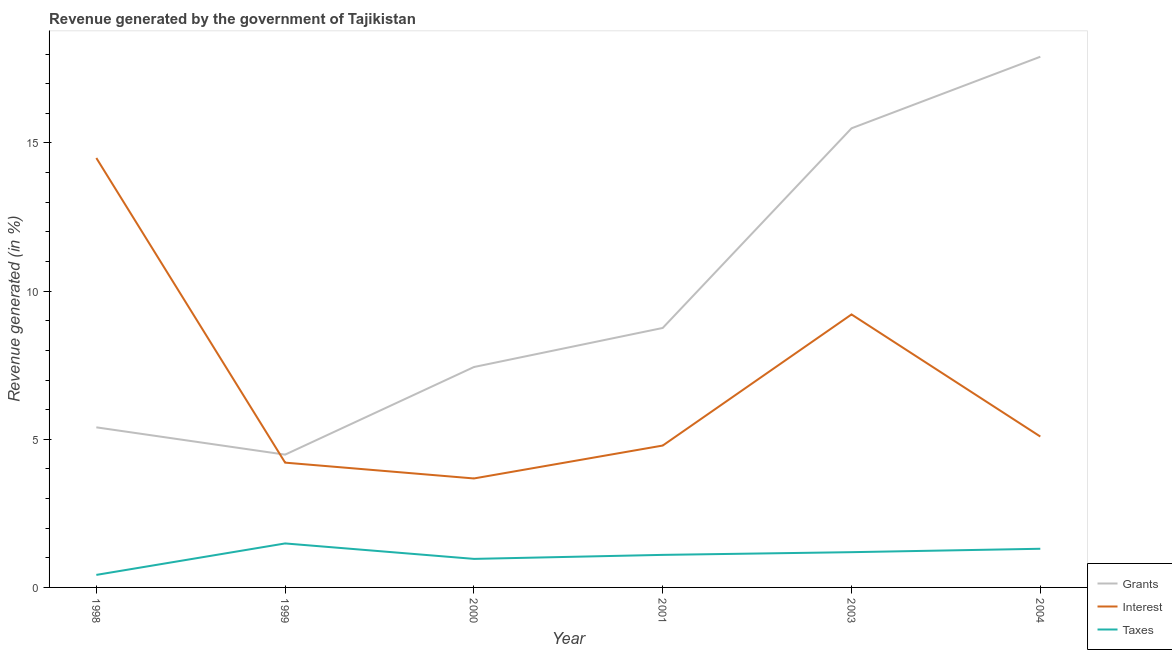Does the line corresponding to percentage of revenue generated by interest intersect with the line corresponding to percentage of revenue generated by taxes?
Ensure brevity in your answer.  No. What is the percentage of revenue generated by taxes in 2001?
Your answer should be very brief. 1.1. Across all years, what is the maximum percentage of revenue generated by grants?
Make the answer very short. 17.91. Across all years, what is the minimum percentage of revenue generated by grants?
Provide a succinct answer. 4.48. In which year was the percentage of revenue generated by taxes minimum?
Your response must be concise. 1998. What is the total percentage of revenue generated by taxes in the graph?
Offer a very short reply. 6.46. What is the difference between the percentage of revenue generated by interest in 1999 and that in 2001?
Ensure brevity in your answer.  -0.58. What is the difference between the percentage of revenue generated by taxes in 2001 and the percentage of revenue generated by grants in 2003?
Offer a terse response. -14.4. What is the average percentage of revenue generated by grants per year?
Provide a succinct answer. 9.91. In the year 1998, what is the difference between the percentage of revenue generated by interest and percentage of revenue generated by grants?
Your answer should be compact. 9.09. What is the ratio of the percentage of revenue generated by grants in 1998 to that in 2000?
Provide a short and direct response. 0.73. Is the percentage of revenue generated by taxes in 1999 less than that in 2003?
Your response must be concise. No. Is the difference between the percentage of revenue generated by interest in 2000 and 2004 greater than the difference between the percentage of revenue generated by grants in 2000 and 2004?
Provide a short and direct response. Yes. What is the difference between the highest and the second highest percentage of revenue generated by taxes?
Your response must be concise. 0.18. What is the difference between the highest and the lowest percentage of revenue generated by taxes?
Offer a very short reply. 1.06. Is it the case that in every year, the sum of the percentage of revenue generated by grants and percentage of revenue generated by interest is greater than the percentage of revenue generated by taxes?
Your answer should be compact. Yes. Does the percentage of revenue generated by interest monotonically increase over the years?
Give a very brief answer. No. Is the percentage of revenue generated by taxes strictly less than the percentage of revenue generated by grants over the years?
Your answer should be compact. Yes. How many lines are there?
Offer a very short reply. 3. How many years are there in the graph?
Offer a terse response. 6. Are the values on the major ticks of Y-axis written in scientific E-notation?
Give a very brief answer. No. Does the graph contain any zero values?
Keep it short and to the point. No. How many legend labels are there?
Offer a terse response. 3. What is the title of the graph?
Offer a terse response. Revenue generated by the government of Tajikistan. Does "Infant(female)" appear as one of the legend labels in the graph?
Offer a very short reply. No. What is the label or title of the X-axis?
Provide a short and direct response. Year. What is the label or title of the Y-axis?
Ensure brevity in your answer.  Revenue generated (in %). What is the Revenue generated (in %) in Grants in 1998?
Your answer should be very brief. 5.4. What is the Revenue generated (in %) of Interest in 1998?
Give a very brief answer. 14.49. What is the Revenue generated (in %) of Taxes in 1998?
Ensure brevity in your answer.  0.42. What is the Revenue generated (in %) in Grants in 1999?
Provide a succinct answer. 4.48. What is the Revenue generated (in %) in Interest in 1999?
Ensure brevity in your answer.  4.21. What is the Revenue generated (in %) of Taxes in 1999?
Make the answer very short. 1.48. What is the Revenue generated (in %) in Grants in 2000?
Offer a very short reply. 7.44. What is the Revenue generated (in %) in Interest in 2000?
Offer a very short reply. 3.68. What is the Revenue generated (in %) in Taxes in 2000?
Provide a succinct answer. 0.96. What is the Revenue generated (in %) of Grants in 2001?
Make the answer very short. 8.76. What is the Revenue generated (in %) in Interest in 2001?
Offer a very short reply. 4.79. What is the Revenue generated (in %) in Taxes in 2001?
Make the answer very short. 1.1. What is the Revenue generated (in %) in Grants in 2003?
Offer a very short reply. 15.5. What is the Revenue generated (in %) in Interest in 2003?
Provide a succinct answer. 9.21. What is the Revenue generated (in %) in Taxes in 2003?
Your response must be concise. 1.19. What is the Revenue generated (in %) of Grants in 2004?
Offer a terse response. 17.91. What is the Revenue generated (in %) in Interest in 2004?
Provide a succinct answer. 5.09. What is the Revenue generated (in %) of Taxes in 2004?
Make the answer very short. 1.3. Across all years, what is the maximum Revenue generated (in %) of Grants?
Keep it short and to the point. 17.91. Across all years, what is the maximum Revenue generated (in %) in Interest?
Give a very brief answer. 14.49. Across all years, what is the maximum Revenue generated (in %) of Taxes?
Offer a terse response. 1.48. Across all years, what is the minimum Revenue generated (in %) in Grants?
Your response must be concise. 4.48. Across all years, what is the minimum Revenue generated (in %) in Interest?
Offer a very short reply. 3.68. Across all years, what is the minimum Revenue generated (in %) in Taxes?
Your response must be concise. 0.42. What is the total Revenue generated (in %) of Grants in the graph?
Make the answer very short. 59.49. What is the total Revenue generated (in %) of Interest in the graph?
Your answer should be very brief. 41.48. What is the total Revenue generated (in %) in Taxes in the graph?
Your answer should be very brief. 6.46. What is the difference between the Revenue generated (in %) in Grants in 1998 and that in 1999?
Provide a succinct answer. 0.92. What is the difference between the Revenue generated (in %) in Interest in 1998 and that in 1999?
Give a very brief answer. 10.28. What is the difference between the Revenue generated (in %) in Taxes in 1998 and that in 1999?
Provide a succinct answer. -1.06. What is the difference between the Revenue generated (in %) in Grants in 1998 and that in 2000?
Provide a succinct answer. -2.04. What is the difference between the Revenue generated (in %) in Interest in 1998 and that in 2000?
Your response must be concise. 10.82. What is the difference between the Revenue generated (in %) in Taxes in 1998 and that in 2000?
Ensure brevity in your answer.  -0.54. What is the difference between the Revenue generated (in %) in Grants in 1998 and that in 2001?
Offer a very short reply. -3.35. What is the difference between the Revenue generated (in %) of Interest in 1998 and that in 2001?
Your response must be concise. 9.7. What is the difference between the Revenue generated (in %) of Taxes in 1998 and that in 2001?
Your answer should be compact. -0.68. What is the difference between the Revenue generated (in %) in Grants in 1998 and that in 2003?
Your answer should be compact. -10.09. What is the difference between the Revenue generated (in %) of Interest in 1998 and that in 2003?
Provide a short and direct response. 5.28. What is the difference between the Revenue generated (in %) of Taxes in 1998 and that in 2003?
Your answer should be very brief. -0.77. What is the difference between the Revenue generated (in %) in Grants in 1998 and that in 2004?
Provide a short and direct response. -12.51. What is the difference between the Revenue generated (in %) in Interest in 1998 and that in 2004?
Provide a succinct answer. 9.4. What is the difference between the Revenue generated (in %) in Taxes in 1998 and that in 2004?
Ensure brevity in your answer.  -0.88. What is the difference between the Revenue generated (in %) of Grants in 1999 and that in 2000?
Make the answer very short. -2.96. What is the difference between the Revenue generated (in %) of Interest in 1999 and that in 2000?
Offer a very short reply. 0.53. What is the difference between the Revenue generated (in %) of Taxes in 1999 and that in 2000?
Give a very brief answer. 0.52. What is the difference between the Revenue generated (in %) of Grants in 1999 and that in 2001?
Your response must be concise. -4.28. What is the difference between the Revenue generated (in %) of Interest in 1999 and that in 2001?
Provide a short and direct response. -0.58. What is the difference between the Revenue generated (in %) in Taxes in 1999 and that in 2001?
Give a very brief answer. 0.39. What is the difference between the Revenue generated (in %) of Grants in 1999 and that in 2003?
Keep it short and to the point. -11.01. What is the difference between the Revenue generated (in %) in Interest in 1999 and that in 2003?
Your answer should be compact. -5. What is the difference between the Revenue generated (in %) of Taxes in 1999 and that in 2003?
Your answer should be compact. 0.29. What is the difference between the Revenue generated (in %) in Grants in 1999 and that in 2004?
Keep it short and to the point. -13.43. What is the difference between the Revenue generated (in %) of Interest in 1999 and that in 2004?
Offer a very short reply. -0.88. What is the difference between the Revenue generated (in %) in Taxes in 1999 and that in 2004?
Your answer should be compact. 0.18. What is the difference between the Revenue generated (in %) of Grants in 2000 and that in 2001?
Ensure brevity in your answer.  -1.32. What is the difference between the Revenue generated (in %) in Interest in 2000 and that in 2001?
Give a very brief answer. -1.11. What is the difference between the Revenue generated (in %) of Taxes in 2000 and that in 2001?
Offer a very short reply. -0.14. What is the difference between the Revenue generated (in %) of Grants in 2000 and that in 2003?
Your answer should be compact. -8.06. What is the difference between the Revenue generated (in %) in Interest in 2000 and that in 2003?
Provide a succinct answer. -5.54. What is the difference between the Revenue generated (in %) of Taxes in 2000 and that in 2003?
Your response must be concise. -0.23. What is the difference between the Revenue generated (in %) in Grants in 2000 and that in 2004?
Give a very brief answer. -10.47. What is the difference between the Revenue generated (in %) of Interest in 2000 and that in 2004?
Ensure brevity in your answer.  -1.41. What is the difference between the Revenue generated (in %) in Taxes in 2000 and that in 2004?
Ensure brevity in your answer.  -0.34. What is the difference between the Revenue generated (in %) in Grants in 2001 and that in 2003?
Offer a terse response. -6.74. What is the difference between the Revenue generated (in %) in Interest in 2001 and that in 2003?
Provide a succinct answer. -4.42. What is the difference between the Revenue generated (in %) of Taxes in 2001 and that in 2003?
Your answer should be very brief. -0.09. What is the difference between the Revenue generated (in %) of Grants in 2001 and that in 2004?
Your response must be concise. -9.15. What is the difference between the Revenue generated (in %) in Interest in 2001 and that in 2004?
Provide a short and direct response. -0.3. What is the difference between the Revenue generated (in %) of Taxes in 2001 and that in 2004?
Provide a succinct answer. -0.21. What is the difference between the Revenue generated (in %) in Grants in 2003 and that in 2004?
Your response must be concise. -2.42. What is the difference between the Revenue generated (in %) in Interest in 2003 and that in 2004?
Your answer should be very brief. 4.12. What is the difference between the Revenue generated (in %) in Taxes in 2003 and that in 2004?
Your answer should be compact. -0.12. What is the difference between the Revenue generated (in %) in Grants in 1998 and the Revenue generated (in %) in Interest in 1999?
Provide a succinct answer. 1.19. What is the difference between the Revenue generated (in %) in Grants in 1998 and the Revenue generated (in %) in Taxes in 1999?
Give a very brief answer. 3.92. What is the difference between the Revenue generated (in %) of Interest in 1998 and the Revenue generated (in %) of Taxes in 1999?
Ensure brevity in your answer.  13.01. What is the difference between the Revenue generated (in %) in Grants in 1998 and the Revenue generated (in %) in Interest in 2000?
Provide a succinct answer. 1.73. What is the difference between the Revenue generated (in %) of Grants in 1998 and the Revenue generated (in %) of Taxes in 2000?
Keep it short and to the point. 4.44. What is the difference between the Revenue generated (in %) in Interest in 1998 and the Revenue generated (in %) in Taxes in 2000?
Your answer should be very brief. 13.53. What is the difference between the Revenue generated (in %) of Grants in 1998 and the Revenue generated (in %) of Interest in 2001?
Provide a short and direct response. 0.61. What is the difference between the Revenue generated (in %) in Grants in 1998 and the Revenue generated (in %) in Taxes in 2001?
Keep it short and to the point. 4.3. What is the difference between the Revenue generated (in %) of Interest in 1998 and the Revenue generated (in %) of Taxes in 2001?
Ensure brevity in your answer.  13.39. What is the difference between the Revenue generated (in %) of Grants in 1998 and the Revenue generated (in %) of Interest in 2003?
Your answer should be compact. -3.81. What is the difference between the Revenue generated (in %) of Grants in 1998 and the Revenue generated (in %) of Taxes in 2003?
Offer a very short reply. 4.21. What is the difference between the Revenue generated (in %) of Interest in 1998 and the Revenue generated (in %) of Taxes in 2003?
Make the answer very short. 13.3. What is the difference between the Revenue generated (in %) of Grants in 1998 and the Revenue generated (in %) of Interest in 2004?
Your answer should be very brief. 0.31. What is the difference between the Revenue generated (in %) in Grants in 1998 and the Revenue generated (in %) in Taxes in 2004?
Give a very brief answer. 4.1. What is the difference between the Revenue generated (in %) in Interest in 1998 and the Revenue generated (in %) in Taxes in 2004?
Offer a terse response. 13.19. What is the difference between the Revenue generated (in %) in Grants in 1999 and the Revenue generated (in %) in Interest in 2000?
Give a very brief answer. 0.8. What is the difference between the Revenue generated (in %) of Grants in 1999 and the Revenue generated (in %) of Taxes in 2000?
Your response must be concise. 3.52. What is the difference between the Revenue generated (in %) of Interest in 1999 and the Revenue generated (in %) of Taxes in 2000?
Your response must be concise. 3.25. What is the difference between the Revenue generated (in %) of Grants in 1999 and the Revenue generated (in %) of Interest in 2001?
Your answer should be compact. -0.31. What is the difference between the Revenue generated (in %) of Grants in 1999 and the Revenue generated (in %) of Taxes in 2001?
Make the answer very short. 3.38. What is the difference between the Revenue generated (in %) in Interest in 1999 and the Revenue generated (in %) in Taxes in 2001?
Make the answer very short. 3.11. What is the difference between the Revenue generated (in %) in Grants in 1999 and the Revenue generated (in %) in Interest in 2003?
Your answer should be very brief. -4.73. What is the difference between the Revenue generated (in %) of Grants in 1999 and the Revenue generated (in %) of Taxes in 2003?
Ensure brevity in your answer.  3.29. What is the difference between the Revenue generated (in %) in Interest in 1999 and the Revenue generated (in %) in Taxes in 2003?
Make the answer very short. 3.02. What is the difference between the Revenue generated (in %) in Grants in 1999 and the Revenue generated (in %) in Interest in 2004?
Make the answer very short. -0.61. What is the difference between the Revenue generated (in %) in Grants in 1999 and the Revenue generated (in %) in Taxes in 2004?
Make the answer very short. 3.18. What is the difference between the Revenue generated (in %) in Interest in 1999 and the Revenue generated (in %) in Taxes in 2004?
Provide a short and direct response. 2.91. What is the difference between the Revenue generated (in %) of Grants in 2000 and the Revenue generated (in %) of Interest in 2001?
Your answer should be very brief. 2.65. What is the difference between the Revenue generated (in %) of Grants in 2000 and the Revenue generated (in %) of Taxes in 2001?
Offer a terse response. 6.34. What is the difference between the Revenue generated (in %) of Interest in 2000 and the Revenue generated (in %) of Taxes in 2001?
Your answer should be very brief. 2.58. What is the difference between the Revenue generated (in %) in Grants in 2000 and the Revenue generated (in %) in Interest in 2003?
Ensure brevity in your answer.  -1.77. What is the difference between the Revenue generated (in %) of Grants in 2000 and the Revenue generated (in %) of Taxes in 2003?
Ensure brevity in your answer.  6.25. What is the difference between the Revenue generated (in %) in Interest in 2000 and the Revenue generated (in %) in Taxes in 2003?
Make the answer very short. 2.49. What is the difference between the Revenue generated (in %) of Grants in 2000 and the Revenue generated (in %) of Interest in 2004?
Your answer should be compact. 2.35. What is the difference between the Revenue generated (in %) of Grants in 2000 and the Revenue generated (in %) of Taxes in 2004?
Provide a succinct answer. 6.13. What is the difference between the Revenue generated (in %) in Interest in 2000 and the Revenue generated (in %) in Taxes in 2004?
Give a very brief answer. 2.37. What is the difference between the Revenue generated (in %) in Grants in 2001 and the Revenue generated (in %) in Interest in 2003?
Your response must be concise. -0.46. What is the difference between the Revenue generated (in %) of Grants in 2001 and the Revenue generated (in %) of Taxes in 2003?
Your response must be concise. 7.57. What is the difference between the Revenue generated (in %) of Interest in 2001 and the Revenue generated (in %) of Taxes in 2003?
Give a very brief answer. 3.6. What is the difference between the Revenue generated (in %) of Grants in 2001 and the Revenue generated (in %) of Interest in 2004?
Offer a terse response. 3.66. What is the difference between the Revenue generated (in %) of Grants in 2001 and the Revenue generated (in %) of Taxes in 2004?
Give a very brief answer. 7.45. What is the difference between the Revenue generated (in %) in Interest in 2001 and the Revenue generated (in %) in Taxes in 2004?
Provide a short and direct response. 3.48. What is the difference between the Revenue generated (in %) of Grants in 2003 and the Revenue generated (in %) of Interest in 2004?
Give a very brief answer. 10.4. What is the difference between the Revenue generated (in %) in Grants in 2003 and the Revenue generated (in %) in Taxes in 2004?
Offer a terse response. 14.19. What is the difference between the Revenue generated (in %) in Interest in 2003 and the Revenue generated (in %) in Taxes in 2004?
Your response must be concise. 7.91. What is the average Revenue generated (in %) of Grants per year?
Ensure brevity in your answer.  9.91. What is the average Revenue generated (in %) of Interest per year?
Make the answer very short. 6.91. What is the average Revenue generated (in %) of Taxes per year?
Offer a terse response. 1.08. In the year 1998, what is the difference between the Revenue generated (in %) in Grants and Revenue generated (in %) in Interest?
Make the answer very short. -9.09. In the year 1998, what is the difference between the Revenue generated (in %) in Grants and Revenue generated (in %) in Taxes?
Your answer should be very brief. 4.98. In the year 1998, what is the difference between the Revenue generated (in %) in Interest and Revenue generated (in %) in Taxes?
Provide a succinct answer. 14.07. In the year 1999, what is the difference between the Revenue generated (in %) of Grants and Revenue generated (in %) of Interest?
Your answer should be compact. 0.27. In the year 1999, what is the difference between the Revenue generated (in %) in Grants and Revenue generated (in %) in Taxes?
Offer a terse response. 3. In the year 1999, what is the difference between the Revenue generated (in %) in Interest and Revenue generated (in %) in Taxes?
Provide a succinct answer. 2.73. In the year 2000, what is the difference between the Revenue generated (in %) in Grants and Revenue generated (in %) in Interest?
Give a very brief answer. 3.76. In the year 2000, what is the difference between the Revenue generated (in %) in Grants and Revenue generated (in %) in Taxes?
Make the answer very short. 6.48. In the year 2000, what is the difference between the Revenue generated (in %) of Interest and Revenue generated (in %) of Taxes?
Your answer should be very brief. 2.71. In the year 2001, what is the difference between the Revenue generated (in %) of Grants and Revenue generated (in %) of Interest?
Provide a short and direct response. 3.97. In the year 2001, what is the difference between the Revenue generated (in %) in Grants and Revenue generated (in %) in Taxes?
Your answer should be very brief. 7.66. In the year 2001, what is the difference between the Revenue generated (in %) in Interest and Revenue generated (in %) in Taxes?
Provide a succinct answer. 3.69. In the year 2003, what is the difference between the Revenue generated (in %) in Grants and Revenue generated (in %) in Interest?
Provide a short and direct response. 6.28. In the year 2003, what is the difference between the Revenue generated (in %) in Grants and Revenue generated (in %) in Taxes?
Your answer should be compact. 14.31. In the year 2003, what is the difference between the Revenue generated (in %) of Interest and Revenue generated (in %) of Taxes?
Your answer should be very brief. 8.02. In the year 2004, what is the difference between the Revenue generated (in %) of Grants and Revenue generated (in %) of Interest?
Ensure brevity in your answer.  12.82. In the year 2004, what is the difference between the Revenue generated (in %) in Grants and Revenue generated (in %) in Taxes?
Provide a succinct answer. 16.61. In the year 2004, what is the difference between the Revenue generated (in %) of Interest and Revenue generated (in %) of Taxes?
Offer a terse response. 3.79. What is the ratio of the Revenue generated (in %) in Grants in 1998 to that in 1999?
Ensure brevity in your answer.  1.21. What is the ratio of the Revenue generated (in %) of Interest in 1998 to that in 1999?
Give a very brief answer. 3.44. What is the ratio of the Revenue generated (in %) in Taxes in 1998 to that in 1999?
Provide a succinct answer. 0.28. What is the ratio of the Revenue generated (in %) of Grants in 1998 to that in 2000?
Give a very brief answer. 0.73. What is the ratio of the Revenue generated (in %) of Interest in 1998 to that in 2000?
Make the answer very short. 3.94. What is the ratio of the Revenue generated (in %) in Taxes in 1998 to that in 2000?
Make the answer very short. 0.44. What is the ratio of the Revenue generated (in %) of Grants in 1998 to that in 2001?
Provide a short and direct response. 0.62. What is the ratio of the Revenue generated (in %) in Interest in 1998 to that in 2001?
Your answer should be very brief. 3.03. What is the ratio of the Revenue generated (in %) of Taxes in 1998 to that in 2001?
Keep it short and to the point. 0.38. What is the ratio of the Revenue generated (in %) of Grants in 1998 to that in 2003?
Your answer should be compact. 0.35. What is the ratio of the Revenue generated (in %) of Interest in 1998 to that in 2003?
Give a very brief answer. 1.57. What is the ratio of the Revenue generated (in %) in Taxes in 1998 to that in 2003?
Your answer should be very brief. 0.36. What is the ratio of the Revenue generated (in %) in Grants in 1998 to that in 2004?
Your answer should be very brief. 0.3. What is the ratio of the Revenue generated (in %) in Interest in 1998 to that in 2004?
Give a very brief answer. 2.85. What is the ratio of the Revenue generated (in %) of Taxes in 1998 to that in 2004?
Your response must be concise. 0.32. What is the ratio of the Revenue generated (in %) in Grants in 1999 to that in 2000?
Make the answer very short. 0.6. What is the ratio of the Revenue generated (in %) in Interest in 1999 to that in 2000?
Keep it short and to the point. 1.15. What is the ratio of the Revenue generated (in %) in Taxes in 1999 to that in 2000?
Ensure brevity in your answer.  1.54. What is the ratio of the Revenue generated (in %) in Grants in 1999 to that in 2001?
Keep it short and to the point. 0.51. What is the ratio of the Revenue generated (in %) in Interest in 1999 to that in 2001?
Offer a very short reply. 0.88. What is the ratio of the Revenue generated (in %) of Taxes in 1999 to that in 2001?
Make the answer very short. 1.35. What is the ratio of the Revenue generated (in %) of Grants in 1999 to that in 2003?
Your response must be concise. 0.29. What is the ratio of the Revenue generated (in %) in Interest in 1999 to that in 2003?
Your answer should be compact. 0.46. What is the ratio of the Revenue generated (in %) in Taxes in 1999 to that in 2003?
Offer a very short reply. 1.25. What is the ratio of the Revenue generated (in %) in Grants in 1999 to that in 2004?
Your response must be concise. 0.25. What is the ratio of the Revenue generated (in %) in Interest in 1999 to that in 2004?
Provide a short and direct response. 0.83. What is the ratio of the Revenue generated (in %) of Taxes in 1999 to that in 2004?
Offer a terse response. 1.14. What is the ratio of the Revenue generated (in %) in Grants in 2000 to that in 2001?
Make the answer very short. 0.85. What is the ratio of the Revenue generated (in %) in Interest in 2000 to that in 2001?
Provide a succinct answer. 0.77. What is the ratio of the Revenue generated (in %) in Taxes in 2000 to that in 2001?
Offer a terse response. 0.88. What is the ratio of the Revenue generated (in %) of Grants in 2000 to that in 2003?
Make the answer very short. 0.48. What is the ratio of the Revenue generated (in %) of Interest in 2000 to that in 2003?
Provide a succinct answer. 0.4. What is the ratio of the Revenue generated (in %) in Taxes in 2000 to that in 2003?
Give a very brief answer. 0.81. What is the ratio of the Revenue generated (in %) of Grants in 2000 to that in 2004?
Provide a short and direct response. 0.42. What is the ratio of the Revenue generated (in %) in Interest in 2000 to that in 2004?
Ensure brevity in your answer.  0.72. What is the ratio of the Revenue generated (in %) of Taxes in 2000 to that in 2004?
Provide a succinct answer. 0.74. What is the ratio of the Revenue generated (in %) of Grants in 2001 to that in 2003?
Offer a terse response. 0.57. What is the ratio of the Revenue generated (in %) of Interest in 2001 to that in 2003?
Keep it short and to the point. 0.52. What is the ratio of the Revenue generated (in %) of Taxes in 2001 to that in 2003?
Give a very brief answer. 0.92. What is the ratio of the Revenue generated (in %) of Grants in 2001 to that in 2004?
Ensure brevity in your answer.  0.49. What is the ratio of the Revenue generated (in %) in Interest in 2001 to that in 2004?
Make the answer very short. 0.94. What is the ratio of the Revenue generated (in %) of Taxes in 2001 to that in 2004?
Give a very brief answer. 0.84. What is the ratio of the Revenue generated (in %) of Grants in 2003 to that in 2004?
Give a very brief answer. 0.87. What is the ratio of the Revenue generated (in %) of Interest in 2003 to that in 2004?
Your answer should be very brief. 1.81. What is the ratio of the Revenue generated (in %) of Taxes in 2003 to that in 2004?
Ensure brevity in your answer.  0.91. What is the difference between the highest and the second highest Revenue generated (in %) in Grants?
Your answer should be compact. 2.42. What is the difference between the highest and the second highest Revenue generated (in %) of Interest?
Ensure brevity in your answer.  5.28. What is the difference between the highest and the second highest Revenue generated (in %) in Taxes?
Your response must be concise. 0.18. What is the difference between the highest and the lowest Revenue generated (in %) of Grants?
Provide a short and direct response. 13.43. What is the difference between the highest and the lowest Revenue generated (in %) in Interest?
Provide a succinct answer. 10.82. What is the difference between the highest and the lowest Revenue generated (in %) in Taxes?
Ensure brevity in your answer.  1.06. 